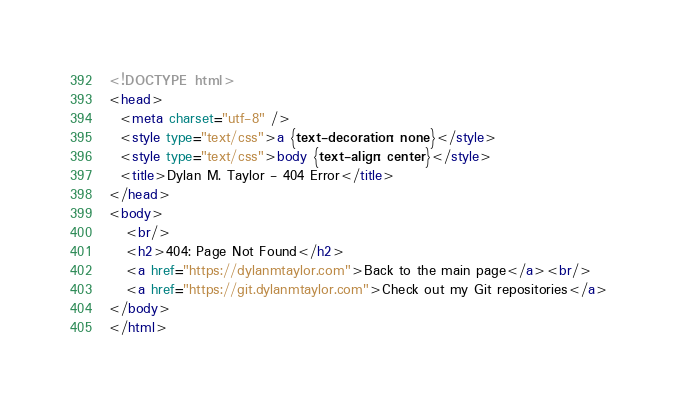Convert code to text. <code><loc_0><loc_0><loc_500><loc_500><_HTML_><!DOCTYPE html>
<head>
  <meta charset="utf-8" />
  <style type="text/css">a {text-decoration: none}</style>
  <style type="text/css">body {text-align: center}</style>
  <title>Dylan M. Taylor - 404 Error</title>
</head>
<body>
   <br/>
   <h2>404: Page Not Found</h2>
   <a href="https://dylanmtaylor.com">Back to the main page</a><br/>
   <a href="https://git.dylanmtaylor.com">Check out my Git repositories</a>
</body>
</html>

</code> 